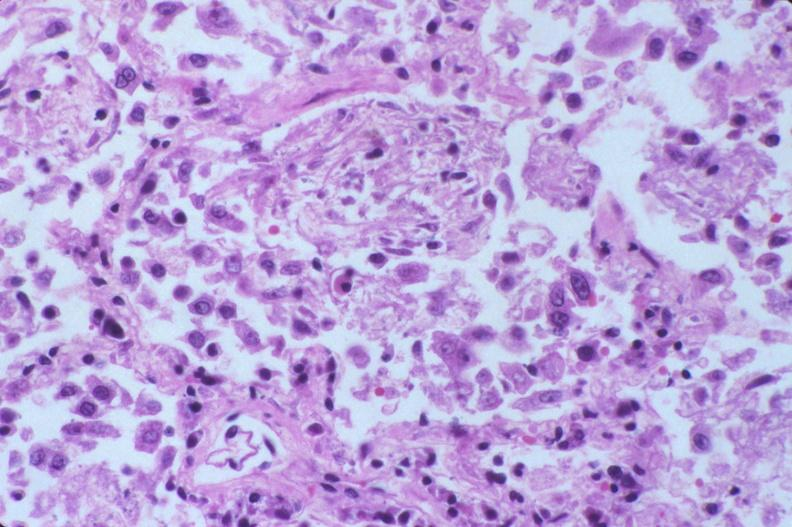does this image show lung, diffuse alveolar damage?
Answer the question using a single word or phrase. Yes 